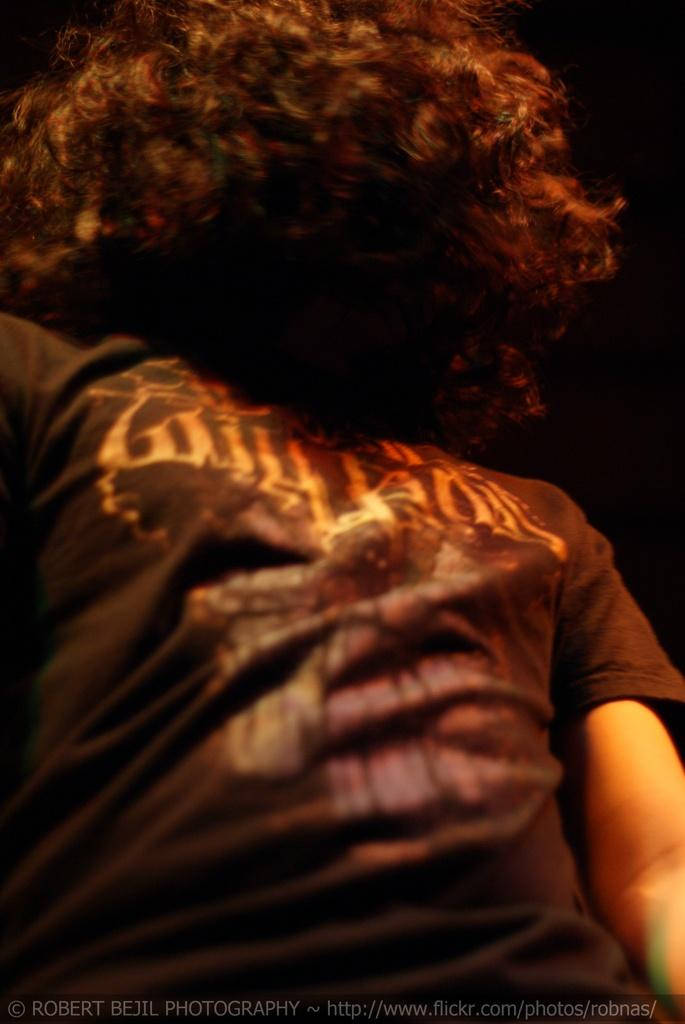Who is present in the image? There is a person in the image. What is the person wearing? The person is wearing a t-shirt. Can you describe the person's hair? The person has curly hair. What is the color or tone of the background in the image? The background of the image is dark. What type of giants can be seen in the background of the image? There are no giants present in the image; the background is dark, but no specific objects or beings are mentioned. 